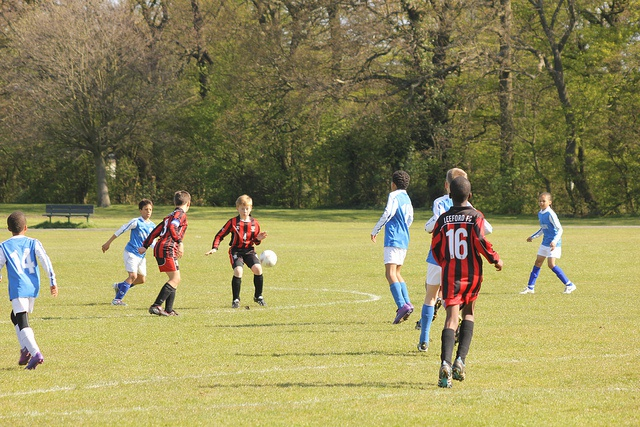Describe the objects in this image and their specific colors. I can see people in tan, black, brown, gray, and maroon tones, people in tan, lavender, lightblue, darkgray, and black tones, people in tan, white, lightblue, blue, and gray tones, people in tan, black, and khaki tones, and people in tan, black, brown, and gray tones in this image. 